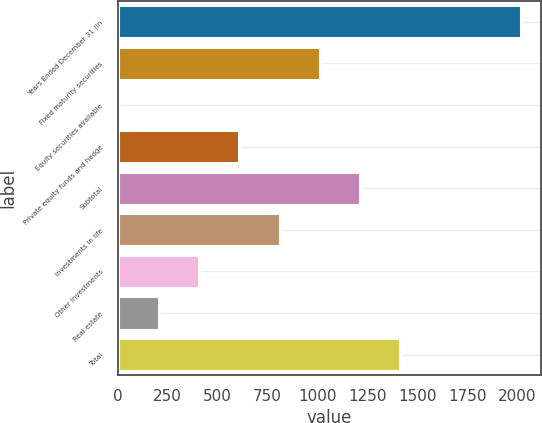Convert chart. <chart><loc_0><loc_0><loc_500><loc_500><bar_chart><fcel>Years Ended December 31 (in<fcel>Fixed maturity securities<fcel>Equity securities available<fcel>Private equity funds and hedge<fcel>Subtotal<fcel>Investments in life<fcel>Other investments<fcel>Real estate<fcel>Total<nl><fcel>2016<fcel>1011.5<fcel>7<fcel>609.7<fcel>1212.4<fcel>810.6<fcel>408.8<fcel>207.9<fcel>1413.3<nl></chart> 